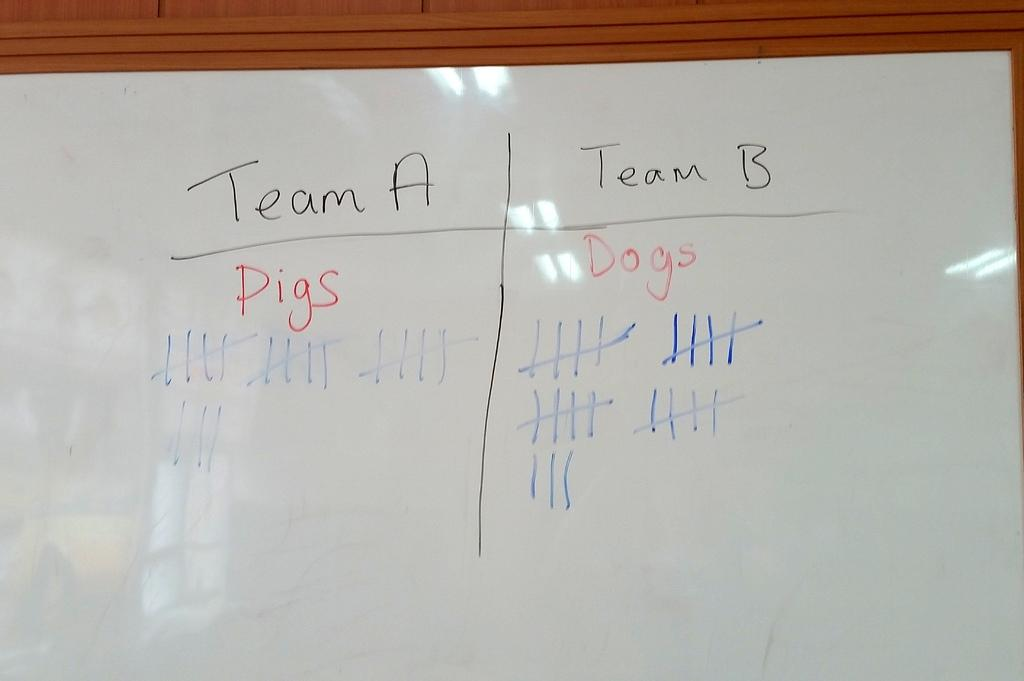<image>
Summarize the visual content of the image. A whiteboard has a tally for Team A and Team B on it. 